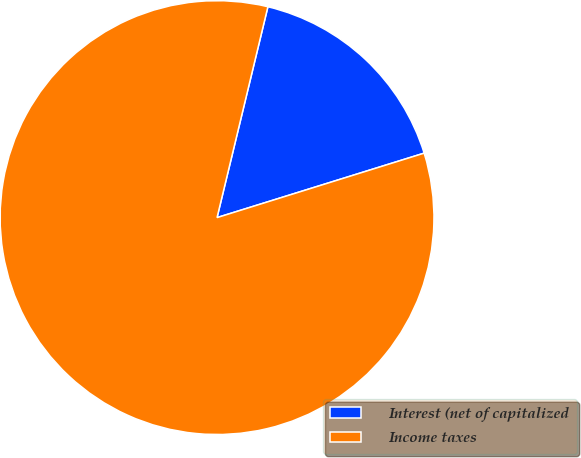Convert chart. <chart><loc_0><loc_0><loc_500><loc_500><pie_chart><fcel>Interest (net of capitalized<fcel>Income taxes<nl><fcel>16.43%<fcel>83.57%<nl></chart> 